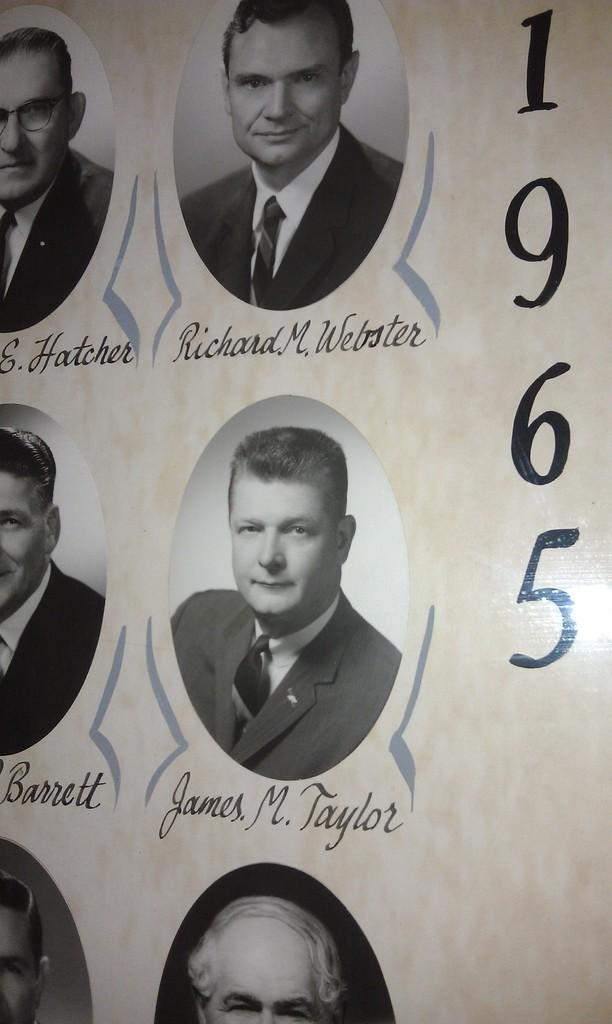Can you describe this image briefly? In this image there are photos of people with their names , and there are numbers on the paper. 